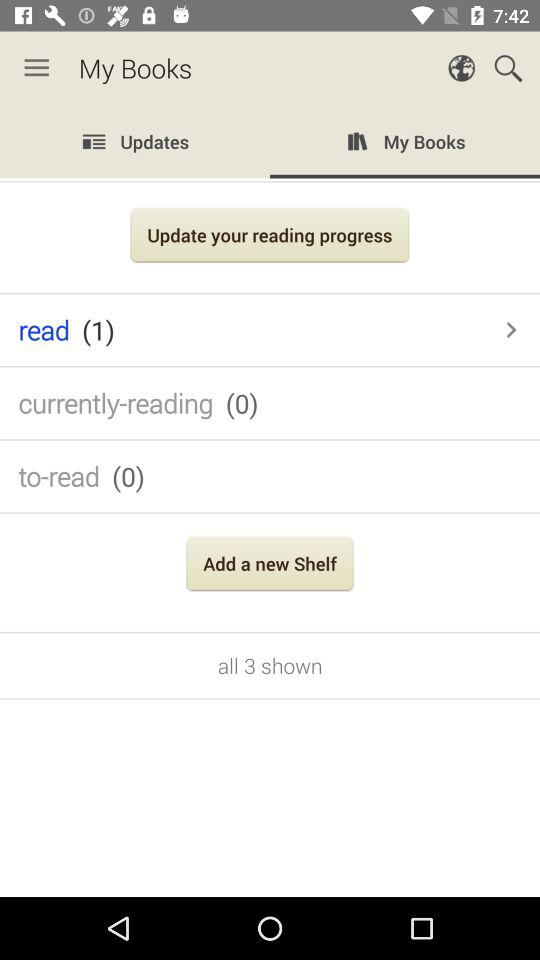What is the selected tab? The selected tab is "My Books". 